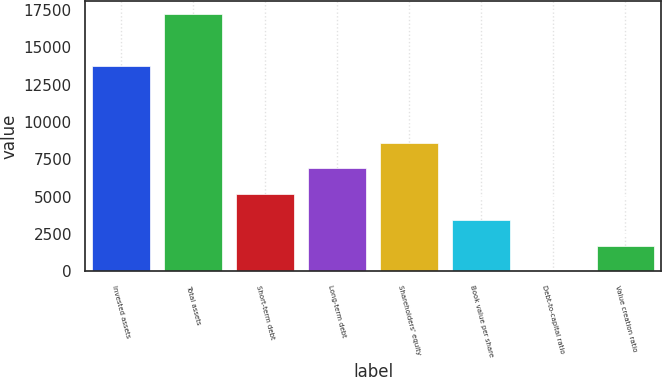Convert chart to OTSL. <chart><loc_0><loc_0><loc_500><loc_500><bar_chart><fcel>Invested assets<fcel>Total assets<fcel>Short-term debt<fcel>Long-term debt<fcel>Shareholders' equity<fcel>Book value per share<fcel>Debt-to-capital ratio<fcel>Value creation ratio<nl><fcel>13759<fcel>17222<fcel>5174.3<fcel>6895.4<fcel>8616.5<fcel>3453.2<fcel>11<fcel>1732.1<nl></chart> 